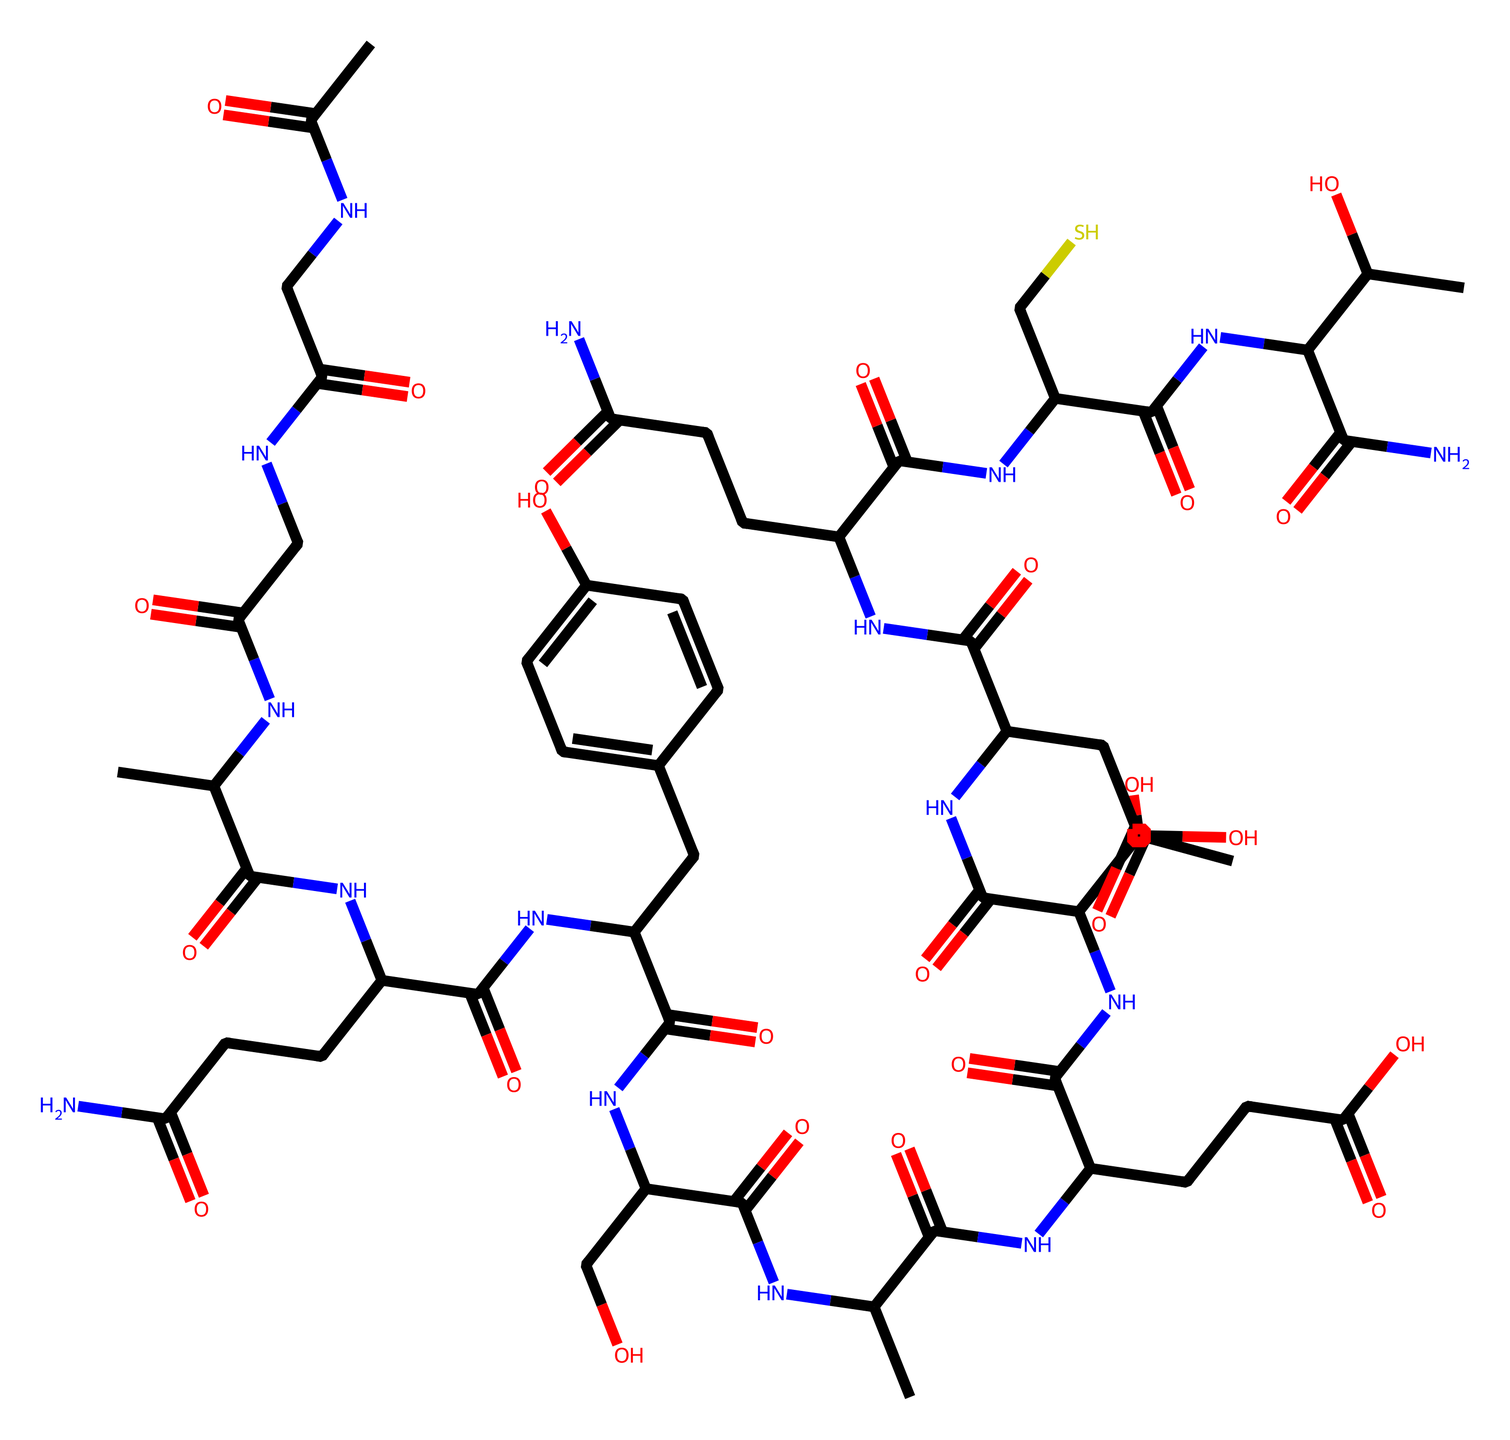What is the main function of collagen in the body? Collagen primarily provides structural support and elasticity to skin and connective tissues, which is vital for maintaining skin firmness and resilience.
Answer: structural support How many carbon atoms are present in this molecule? By analyzing the SMILES structure, each 'C' represents a carbon atom. Counting all carbon symbols gives us the total number, which is 40.
Answer: 40 What functional group is present in the side chains of this collagen molecule? The presence of 'C(=O)' indicates carbonyl functional groups, specifically amide (due to the adjacent nitrogen atoms) and carboxylic acid groups, characteristic of peptide bonds and side chains.
Answer: amide How does the molecular structure of collagen contribute to its strength? Collagen's triple helix structure allows for numerous hydrogen bonds and cross-linking between chains, providing great tensile strength and stability, crucial for its role in connective tissue.
Answer: hydrogen bonds Which type of biological molecule does collagen represent? Collagen is classified as a protein due to its amino acid composition and formation of peptide bonds, characteristic of protein structures.
Answer: protein 